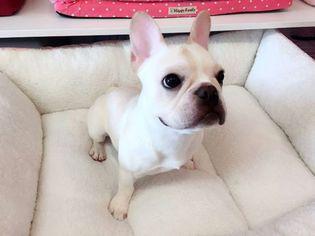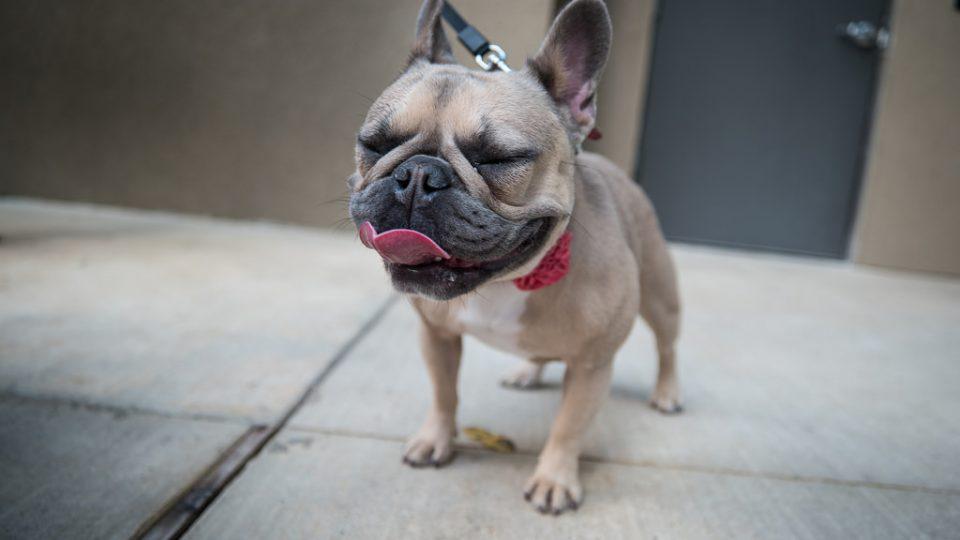The first image is the image on the left, the second image is the image on the right. Examine the images to the left and right. Is the description "The dog in the image on the right is standing on all fours." accurate? Answer yes or no. Yes. 